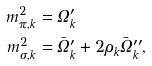Convert formula to latex. <formula><loc_0><loc_0><loc_500><loc_500>m _ { \pi , k } ^ { 2 } & = \Omega _ { k } ^ { \prime } \\ m _ { \sigma , k } ^ { 2 } & = \bar { \Omega } _ { k } ^ { \prime } + 2 \rho _ { k } \bar { \Omega } _ { k } ^ { \prime \prime } ,</formula> 